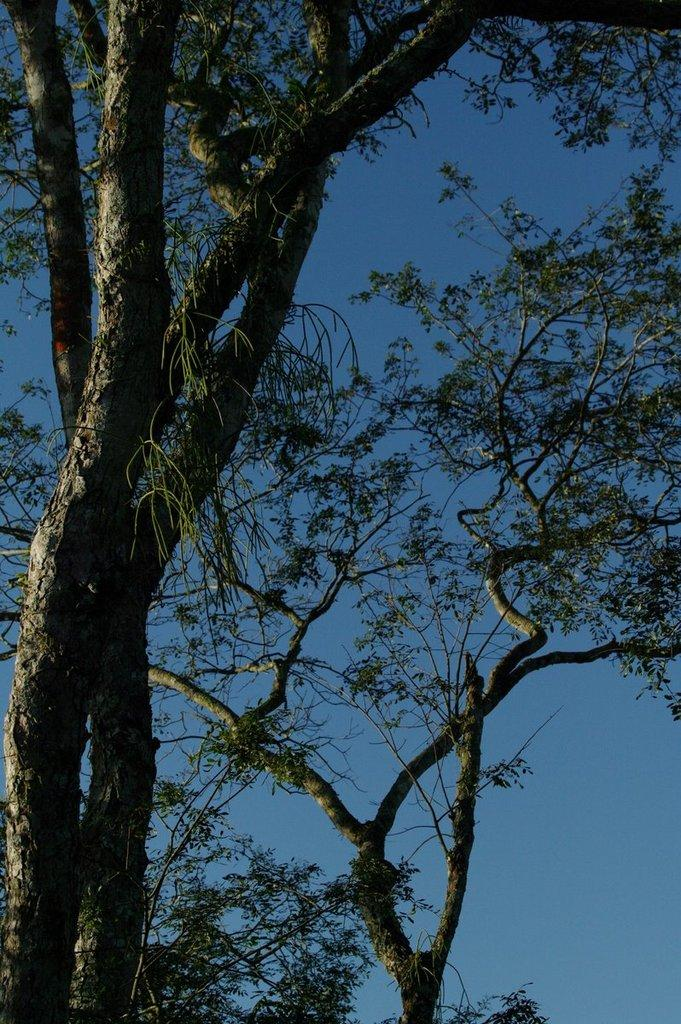What type of vegetation can be seen in the image? There are trees in the image. What part of the natural environment is visible in the image? The sky is visible in the image. Can you determine the time of day based on the image? The image may have been taken in the evening, as the sky appears to be darker. What type of music is the actor playing in the image? There is no actor or music present in the image; it features trees and a sky. 